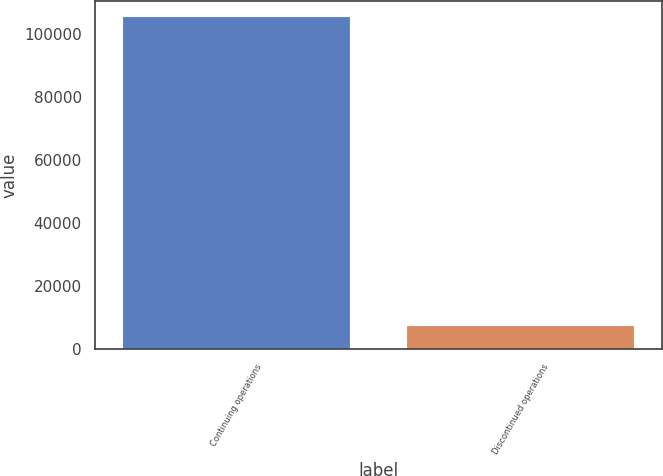Convert chart. <chart><loc_0><loc_0><loc_500><loc_500><bar_chart><fcel>Continuing operations<fcel>Discontinued operations<nl><fcel>105173<fcel>7302<nl></chart> 